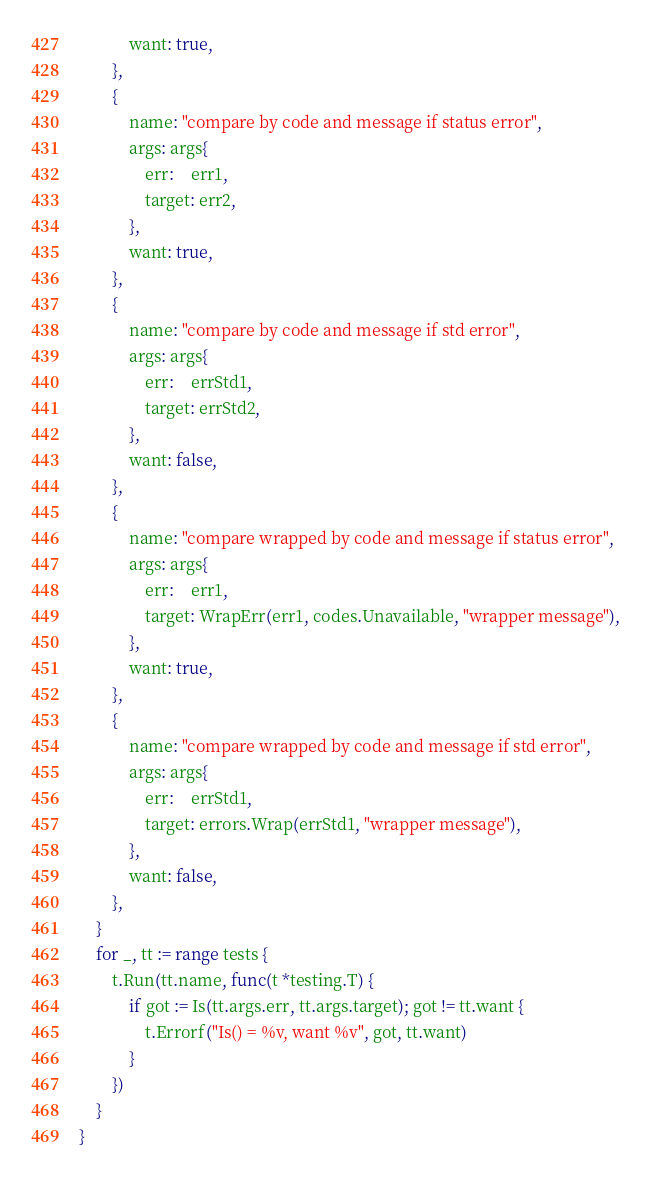Convert code to text. <code><loc_0><loc_0><loc_500><loc_500><_Go_>			want: true,
		},
		{
			name: "compare by code and message if status error",
			args: args{
				err:    err1,
				target: err2,
			},
			want: true,
		},
		{
			name: "compare by code and message if std error",
			args: args{
				err:    errStd1,
				target: errStd2,
			},
			want: false,
		},
		{
			name: "compare wrapped by code and message if status error",
			args: args{
				err:    err1,
				target: WrapErr(err1, codes.Unavailable, "wrapper message"),
			},
			want: true,
		},
		{
			name: "compare wrapped by code and message if std error",
			args: args{
				err:    errStd1,
				target: errors.Wrap(errStd1, "wrapper message"),
			},
			want: false,
		},
	}
	for _, tt := range tests {
		t.Run(tt.name, func(t *testing.T) {
			if got := Is(tt.args.err, tt.args.target); got != tt.want {
				t.Errorf("Is() = %v, want %v", got, tt.want)
			}
		})
	}
}
</code> 